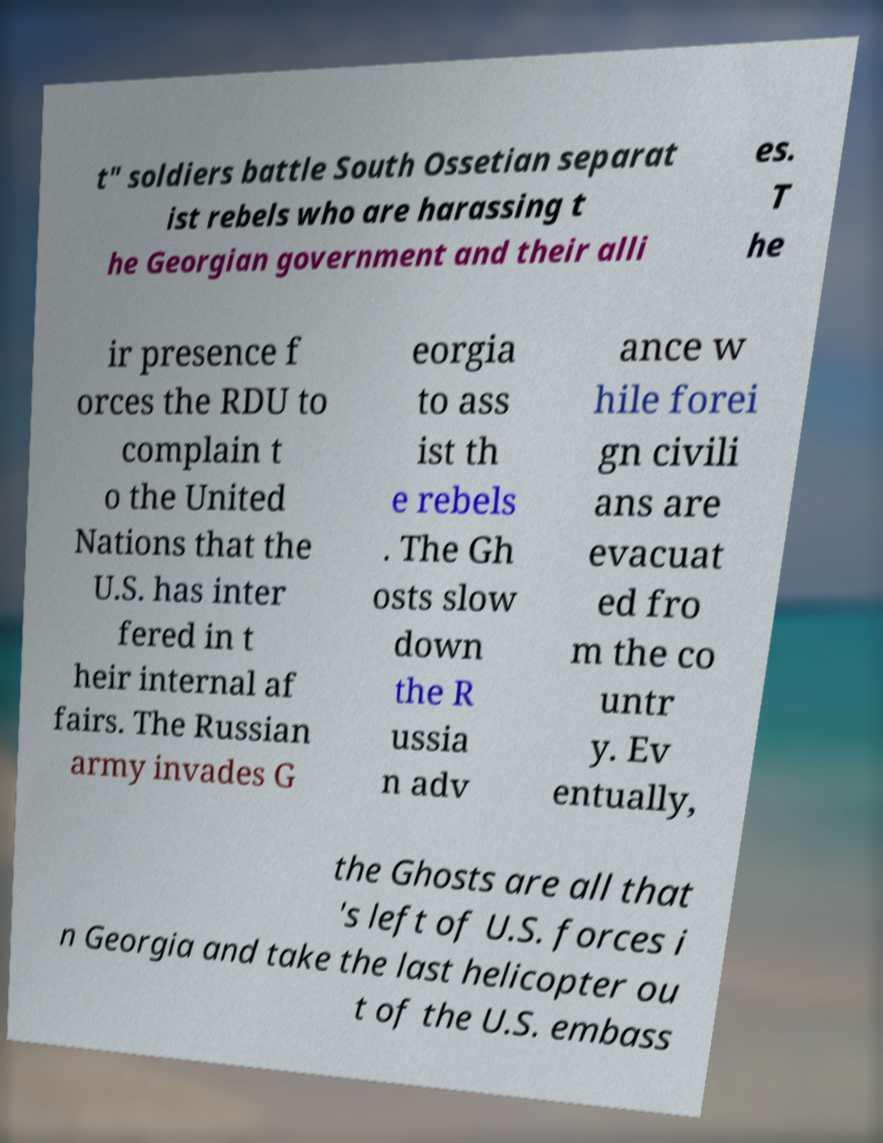Please identify and transcribe the text found in this image. t" soldiers battle South Ossetian separat ist rebels who are harassing t he Georgian government and their alli es. T he ir presence f orces the RDU to complain t o the United Nations that the U.S. has inter fered in t heir internal af fairs. The Russian army invades G eorgia to ass ist th e rebels . The Gh osts slow down the R ussia n adv ance w hile forei gn civili ans are evacuat ed fro m the co untr y. Ev entually, the Ghosts are all that 's left of U.S. forces i n Georgia and take the last helicopter ou t of the U.S. embass 